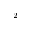Convert formula to latex. <formula><loc_0><loc_0><loc_500><loc_500>^ { - 2 }</formula> 